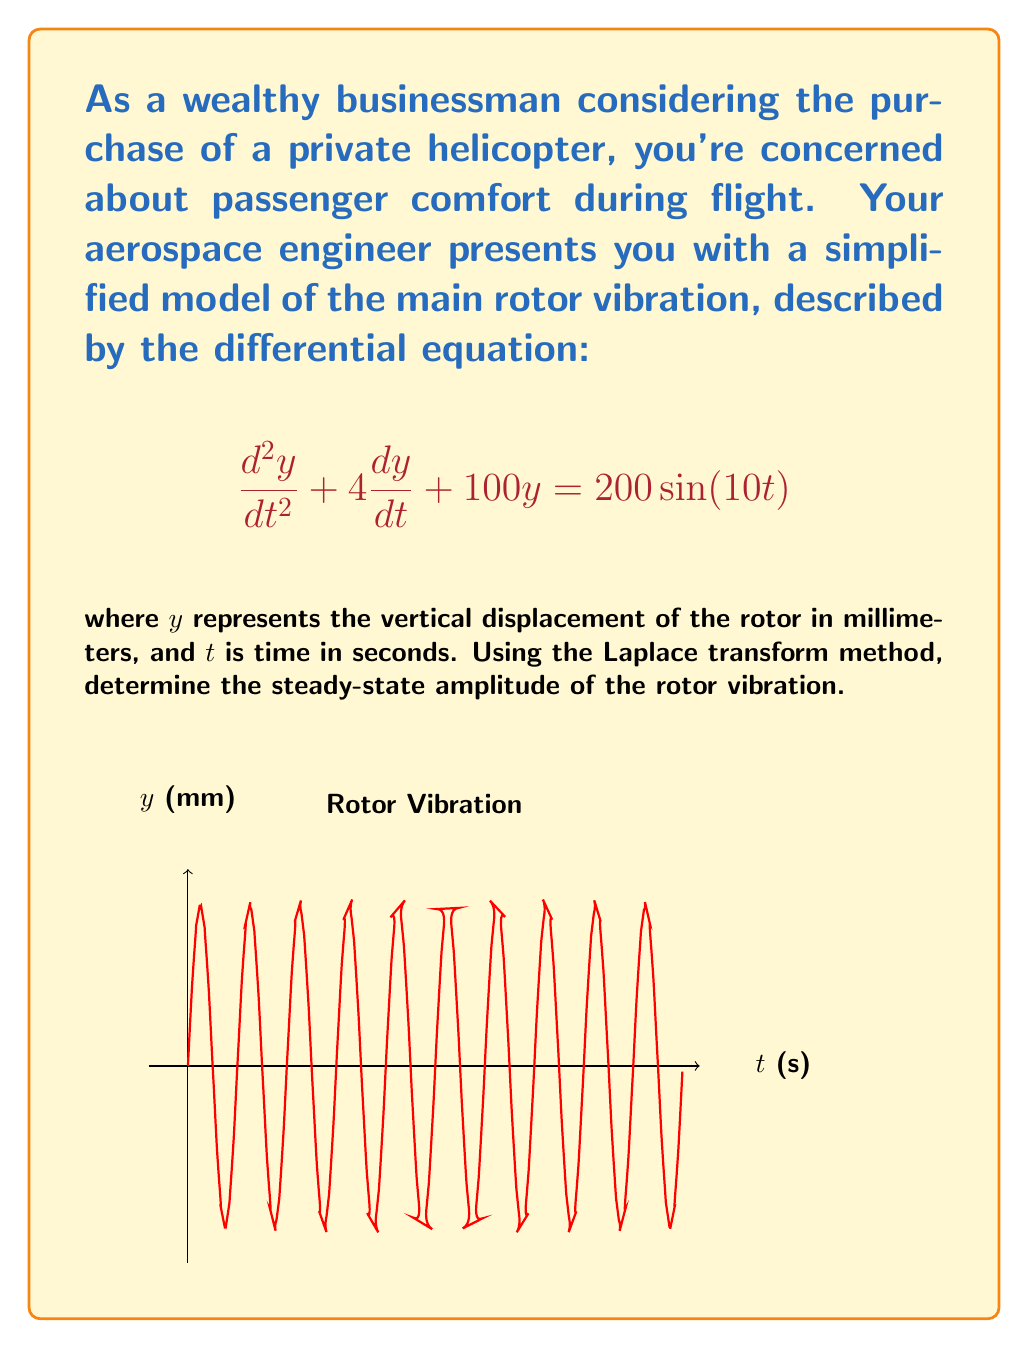Can you answer this question? Let's solve this step-by-step using the Laplace transform method:

1) Take the Laplace transform of both sides of the equation:
   $$\mathcal{L}\{y''\} + 4\mathcal{L}\{y'\} + 100\mathcal{L}\{y\} = 200\mathcal{L}\{\sin(10t)\}$$

2) Using Laplace transform properties:
   $$s^2Y(s) - sy(0) - y'(0) + 4[sY(s) - y(0)] + 100Y(s) = \frac{2000}{s^2 + 100}$$

3) Assuming initial conditions $y(0) = y'(0) = 0$:
   $$(s^2 + 4s + 100)Y(s) = \frac{2000}{s^2 + 100}$$

4) Solve for $Y(s)$:
   $$Y(s) = \frac{2000}{(s^2 + 100)(s^2 + 4s + 100)}$$

5) Use partial fraction decomposition:
   $$Y(s) = \frac{A}{s^2 + 100} + \frac{Bs + C}{s^2 + 4s + 100}$$

6) Solve for $A$, $B$, and $C$. We find $A = 20$, $B = 0$, and $C = -20$.

7) Take the inverse Laplace transform:
   $$y(t) = 20\sin(10t) - 20e^{-2t}\sin(8t)$$

8) The steady-state solution is the part that doesn't decay with time:
   $$y_{ss}(t) = 20\sin(10t)$$

9) The amplitude of this steady-state vibration is 20 mm.
Answer: 20 mm 